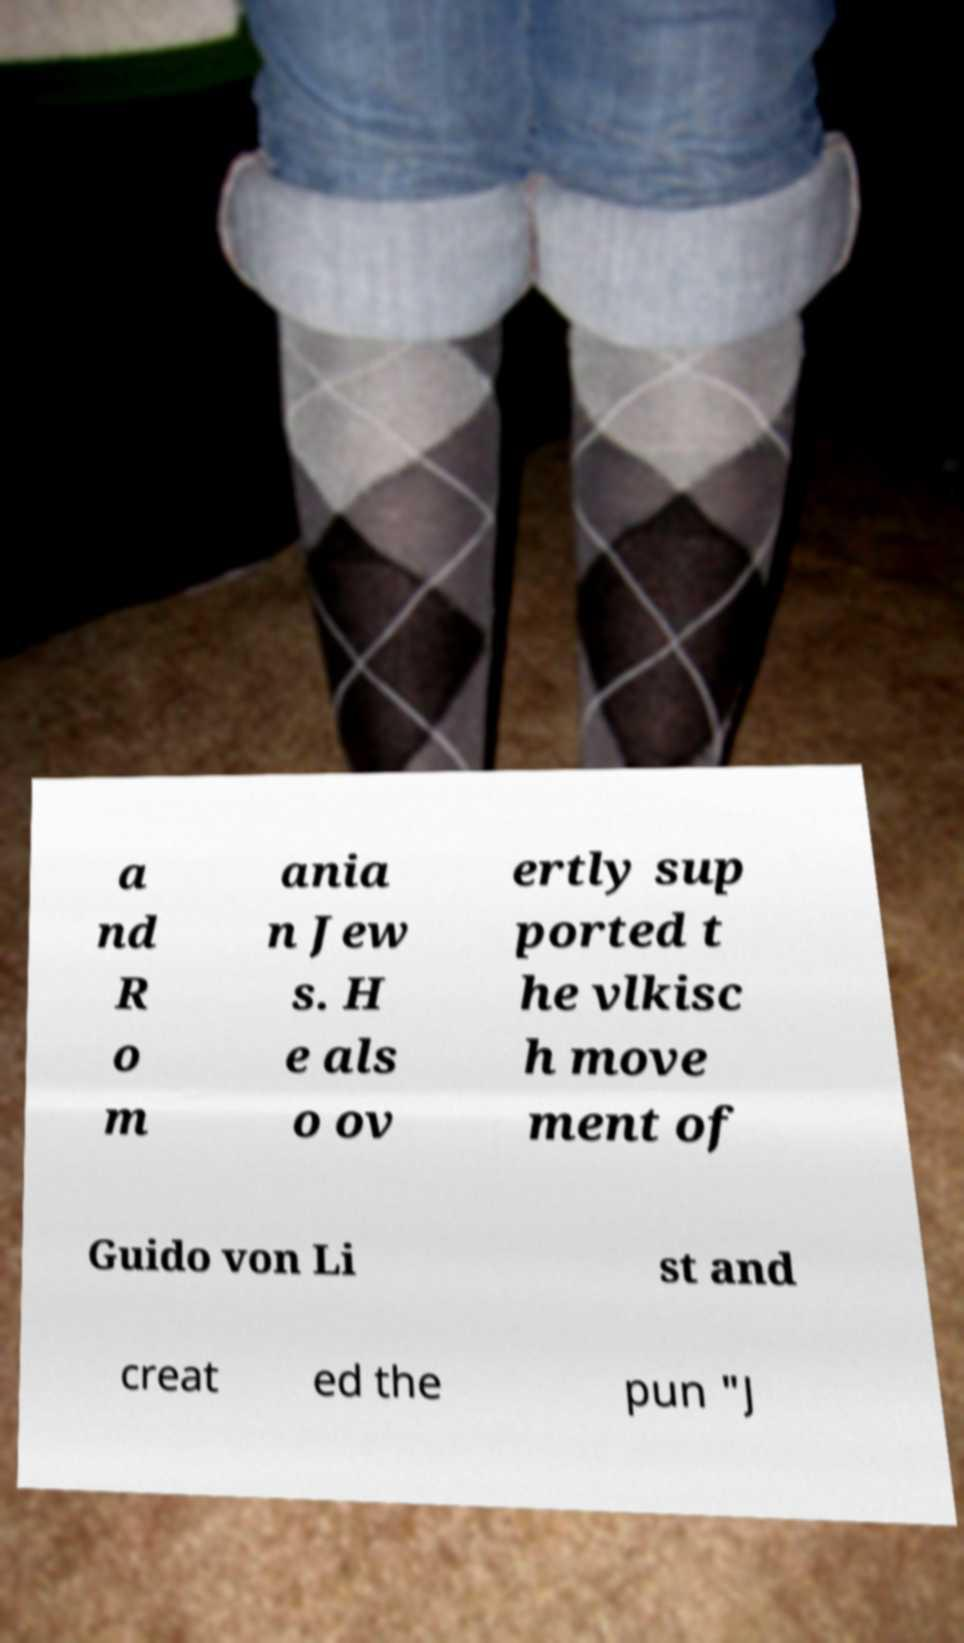Can you accurately transcribe the text from the provided image for me? a nd R o m ania n Jew s. H e als o ov ertly sup ported t he vlkisc h move ment of Guido von Li st and creat ed the pun "J 